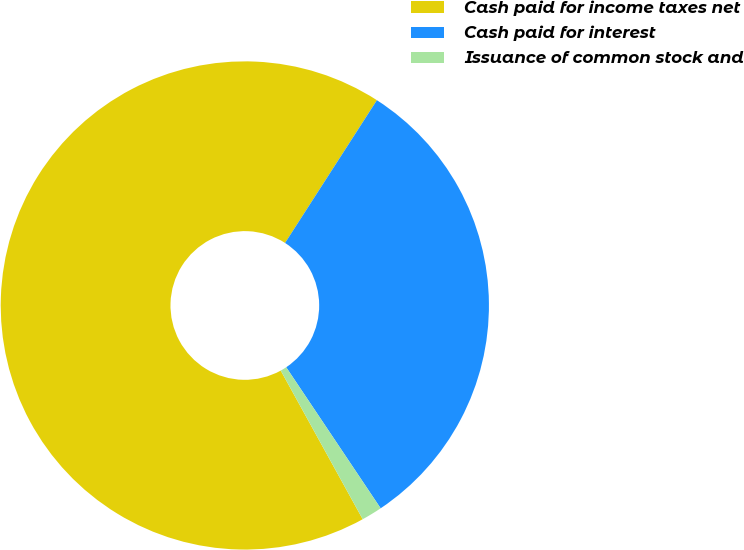<chart> <loc_0><loc_0><loc_500><loc_500><pie_chart><fcel>Cash paid for income taxes net<fcel>Cash paid for interest<fcel>Issuance of common stock and<nl><fcel>67.12%<fcel>31.51%<fcel>1.37%<nl></chart> 